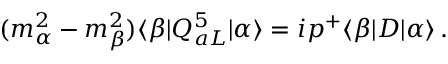Convert formula to latex. <formula><loc_0><loc_0><loc_500><loc_500>( m _ { \alpha } ^ { 2 } - m _ { \beta } ^ { 2 } ) \langle \beta | Q _ { a L } ^ { 5 } | \alpha \rangle = i p ^ { + } \langle \beta | D | \alpha \rangle \, .</formula> 